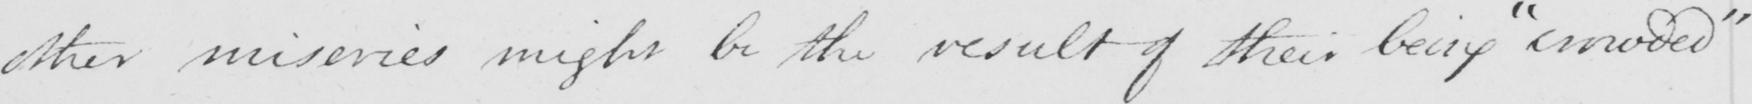Can you tell me what this handwritten text says? other miseries might be the result of their being  " crowded " 